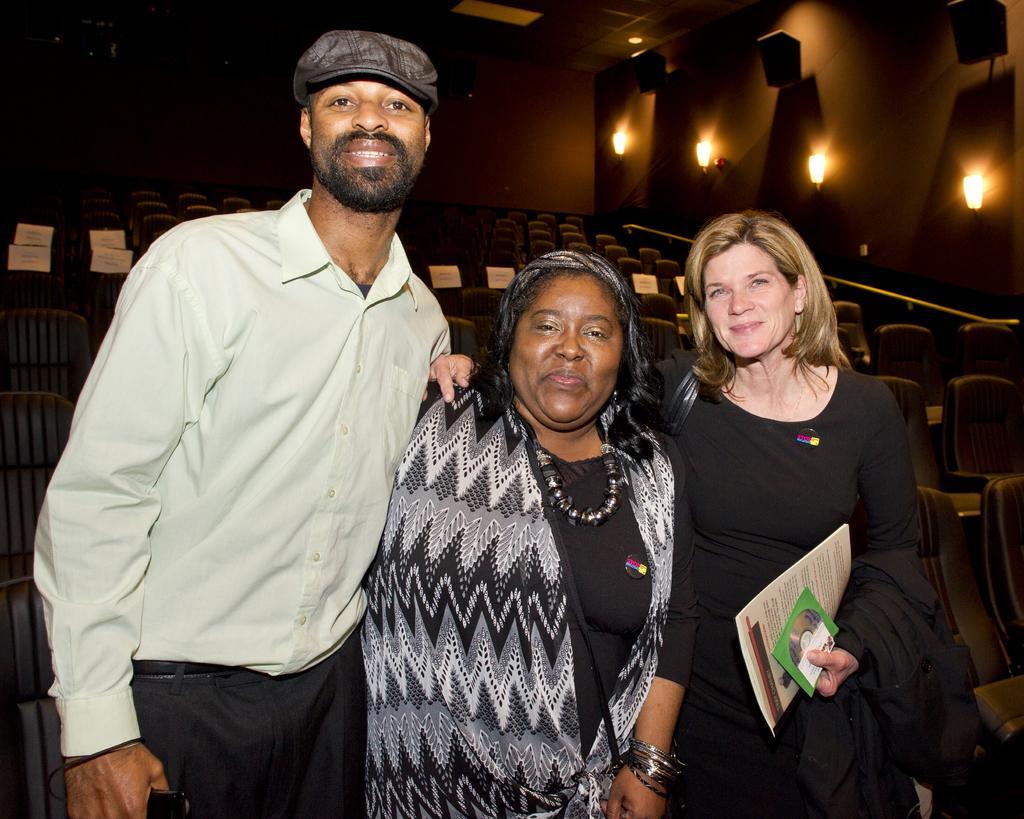Describe this image in one or two sentences. In the middle of the image three persons are standing, smiling and she is holding some books. Behind them we can see some chairs. At the top of the image we can see wall, on the wall we can see some lights and speakers. 